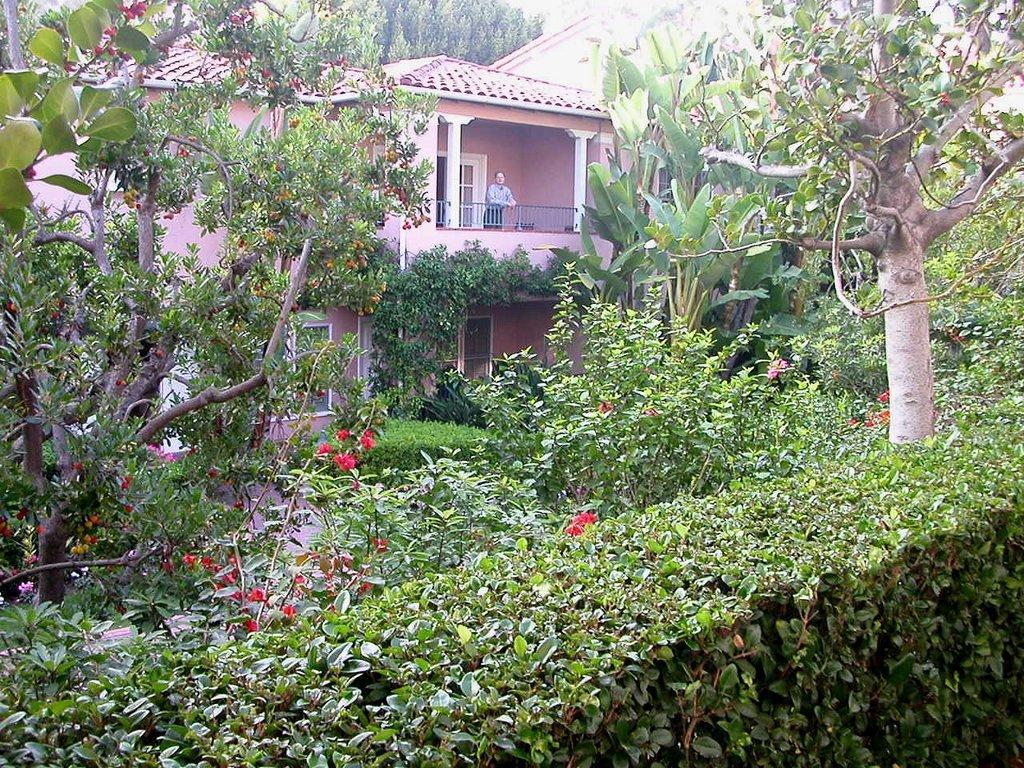In one or two sentences, can you explain what this image depicts? In this picture I can see the plants. I can see flower plants. I can see trees. I can see the house. I can see a person standing. I can see the metal grill fence. 